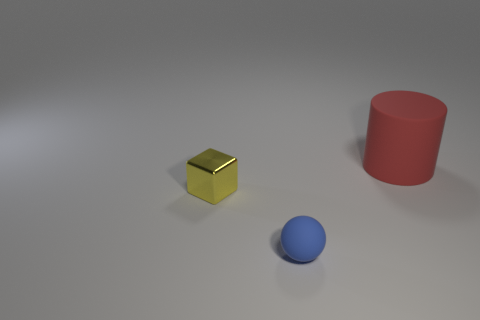Can you describe the colors and shapes of the objects in the image? Certainly! In the image, there are three geometric objects. The first one is a cube with a shiny gold color. The second object is a cylinder with a matte red hue. Lastly, there's a sphere boasting a smooth, matte blue surface. These objects not only represent different forms but they also feature distinctive colors and textures which could be used for educational purposes or artistic expression. 